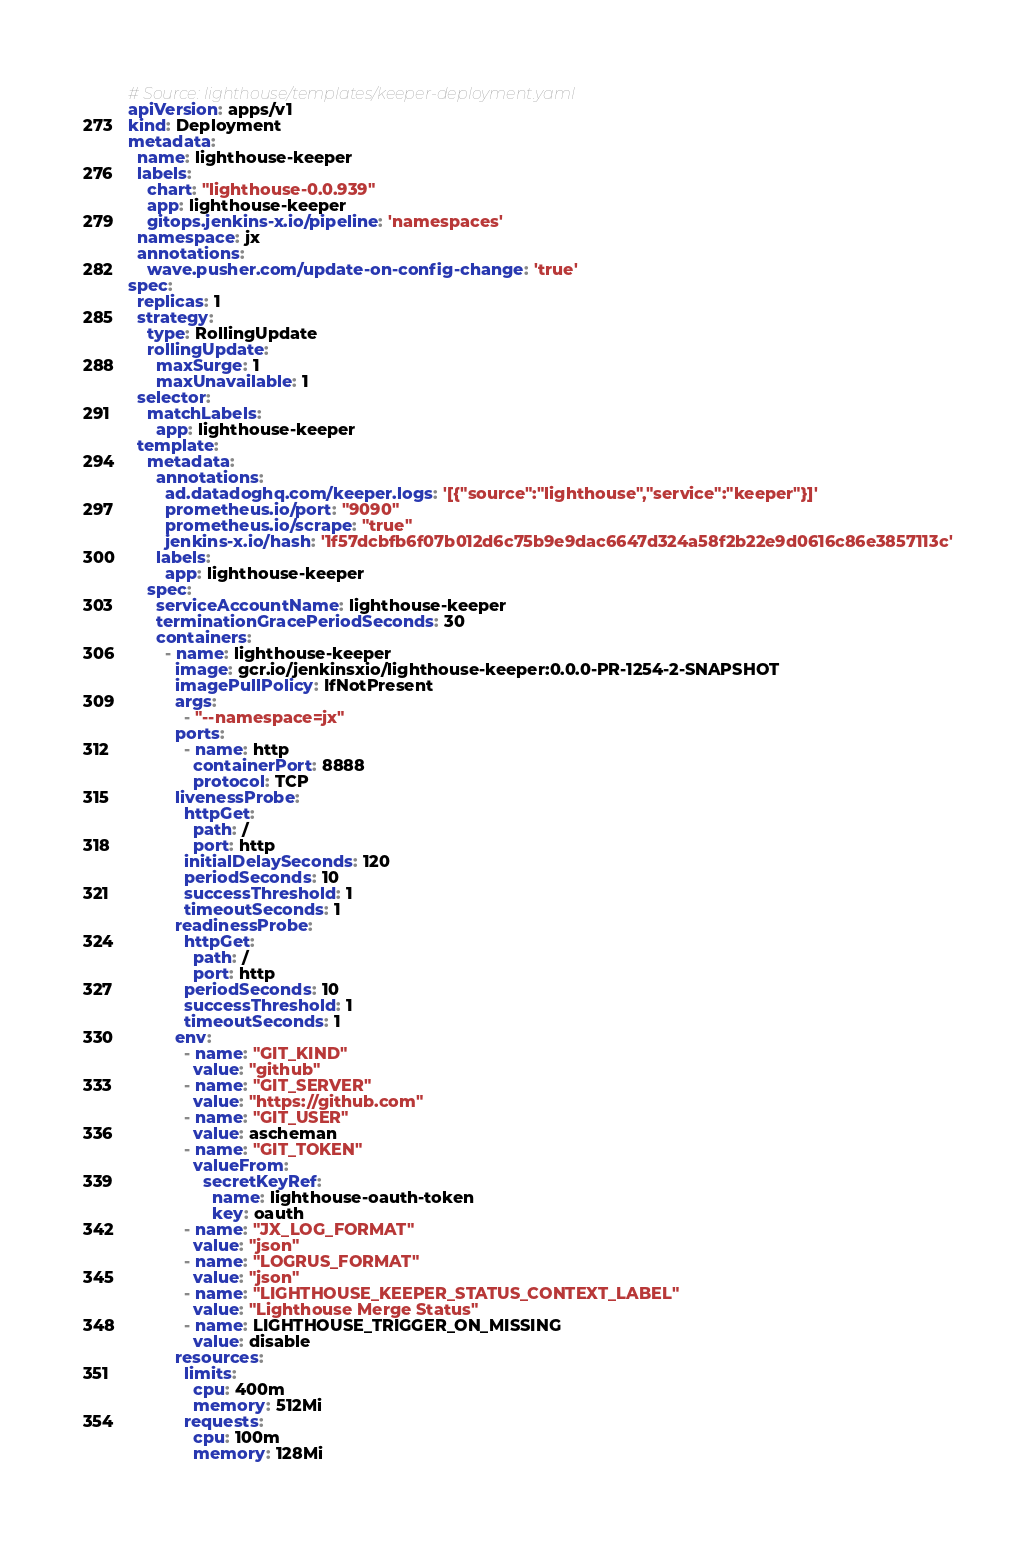<code> <loc_0><loc_0><loc_500><loc_500><_YAML_># Source: lighthouse/templates/keeper-deployment.yaml
apiVersion: apps/v1
kind: Deployment
metadata:
  name: lighthouse-keeper
  labels:
    chart: "lighthouse-0.0.939"
    app: lighthouse-keeper
    gitops.jenkins-x.io/pipeline: 'namespaces'
  namespace: jx
  annotations:
    wave.pusher.com/update-on-config-change: 'true'
spec:
  replicas: 1
  strategy:
    type: RollingUpdate
    rollingUpdate:
      maxSurge: 1
      maxUnavailable: 1
  selector:
    matchLabels:
      app: lighthouse-keeper
  template:
    metadata:
      annotations:
        ad.datadoghq.com/keeper.logs: '[{"source":"lighthouse","service":"keeper"}]'
        prometheus.io/port: "9090"
        prometheus.io/scrape: "true"
        jenkins-x.io/hash: '1f57dcbfb6f07b012d6c75b9e9dac6647d324a58f2b22e9d0616c86e3857113c'
      labels:
        app: lighthouse-keeper
    spec:
      serviceAccountName: lighthouse-keeper
      terminationGracePeriodSeconds: 30
      containers:
        - name: lighthouse-keeper
          image: gcr.io/jenkinsxio/lighthouse-keeper:0.0.0-PR-1254-2-SNAPSHOT
          imagePullPolicy: IfNotPresent
          args:
            - "--namespace=jx"
          ports:
            - name: http
              containerPort: 8888
              protocol: TCP
          livenessProbe:
            httpGet:
              path: /
              port: http
            initialDelaySeconds: 120
            periodSeconds: 10
            successThreshold: 1
            timeoutSeconds: 1
          readinessProbe:
            httpGet:
              path: /
              port: http
            periodSeconds: 10
            successThreshold: 1
            timeoutSeconds: 1
          env:
            - name: "GIT_KIND"
              value: "github"
            - name: "GIT_SERVER"
              value: "https://github.com"
            - name: "GIT_USER"
              value: ascheman
            - name: "GIT_TOKEN"
              valueFrom:
                secretKeyRef:
                  name: lighthouse-oauth-token
                  key: oauth
            - name: "JX_LOG_FORMAT"
              value: "json"
            - name: "LOGRUS_FORMAT"
              value: "json"
            - name: "LIGHTHOUSE_KEEPER_STATUS_CONTEXT_LABEL"
              value: "Lighthouse Merge Status"
            - name: LIGHTHOUSE_TRIGGER_ON_MISSING
              value: disable
          resources:
            limits:
              cpu: 400m
              memory: 512Mi
            requests:
              cpu: 100m
              memory: 128Mi
</code> 